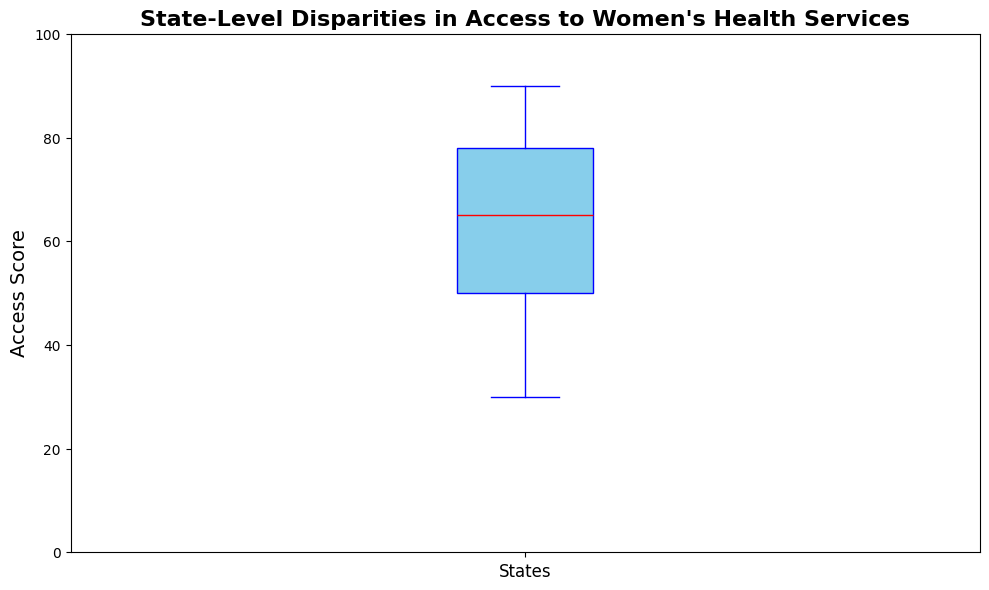What is the median Access Score for the states? The median is shown as a red line within the box in the box plot. Identify this line to find the median value.
Answer: 65 Which state has the lowest Access Score? The lowest Access Score is represented by the bottom whisker of the box plot. Identify the value at this point.
Answer: Mississippi How many states have an Access Score below 45? Look at the lower quartile (bottom section of the box) and count the outliers and data points below this threshold.
Answer: 8 Which part of the plot shows the highest density of scores? The highest density of scores is represented by the range covered by the box itself, which shows the interquartile range (IQR).
Answer: Between 50 and 77 What's the difference between the maximum and minimum Access Scores? The maximum Access Score is at the top whisker (90) and the minimum is at the bottom whisker (30). Subtract the minimum from the maximum.
Answer: 60 How many states have an Access Score of 85 or higher? Identify the outliers and upper whisker points on the box plot that are equal to or greater than 85.
Answer: 4 What visual indicator shows the spread of the middle 50% of the Access Scores? The box in the box plot visualizes the interquartile range (IQR), which contains the middle 50% of the data.
Answer: The box Compare the median Access Score to the lower quartile. Is the median closer to the upper quartile or the lower quartile? The median is in the middle section of the box. Check the distance from the median (red line) to the lower and upper quartiles (bottom and top of the box, respectively).
Answer: Closer to the upper quartile What does the top edge of the box in the plot represent? The top edge of the box represents the upper quartile (75th percentile) of the Access Scores.
Answer: Upper quartile How are outliers depicted in the box plot, and what is one example? Outliers are depicted as green markers outside of the whiskers of the box plot. For example, Hawaii with a score of 90 is an outlier.
Answer: Green markers, e.g., Hawaii at 90 